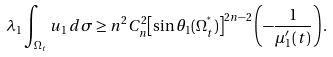<formula> <loc_0><loc_0><loc_500><loc_500>\lambda _ { 1 } \int _ { \Omega _ { t } } u _ { 1 } \, d \sigma \geq n ^ { 2 } C _ { n } ^ { 2 } { \left [ \sin \theta _ { 1 } ( \Omega _ { t } ^ { ^ { * } } ) \right ] } ^ { 2 n - 2 } \left ( - \frac { 1 } { \mu _ { 1 } ^ { \prime } ( t ) } \right ) .</formula> 